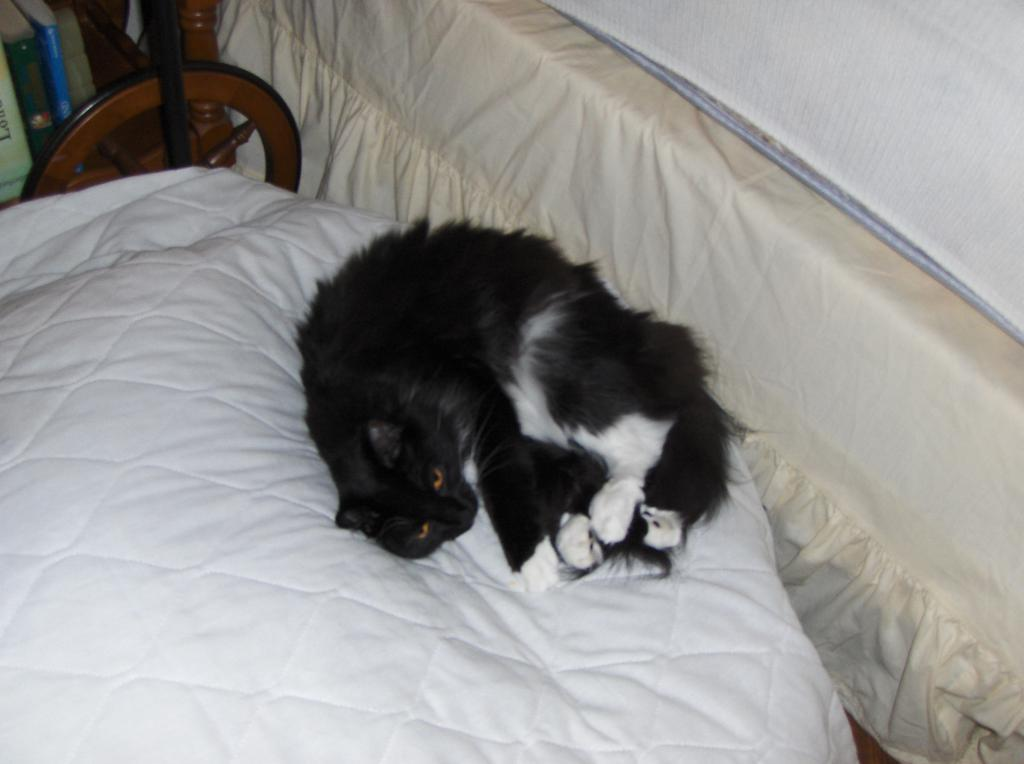What type of animal can be seen in the image? There is a cat in the image. What is the cat doing in the image? The cat is sleeping on the bed. Is there anything covering the cat in the image? The cat may be covered with a blanket. What other object can be seen in the image? There is a wooden object in the image, possibly a table. Is there anything covering the wooden object? The wooden object may be covered with a cloth. What type of juice can be seen in the wilderness in the image? There is no juice or wilderness present in the image; it features a cat sleeping on a bed and a wooden object possibly covered with a cloth. 